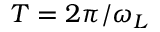Convert formula to latex. <formula><loc_0><loc_0><loc_500><loc_500>T = 2 \pi / \omega _ { L }</formula> 